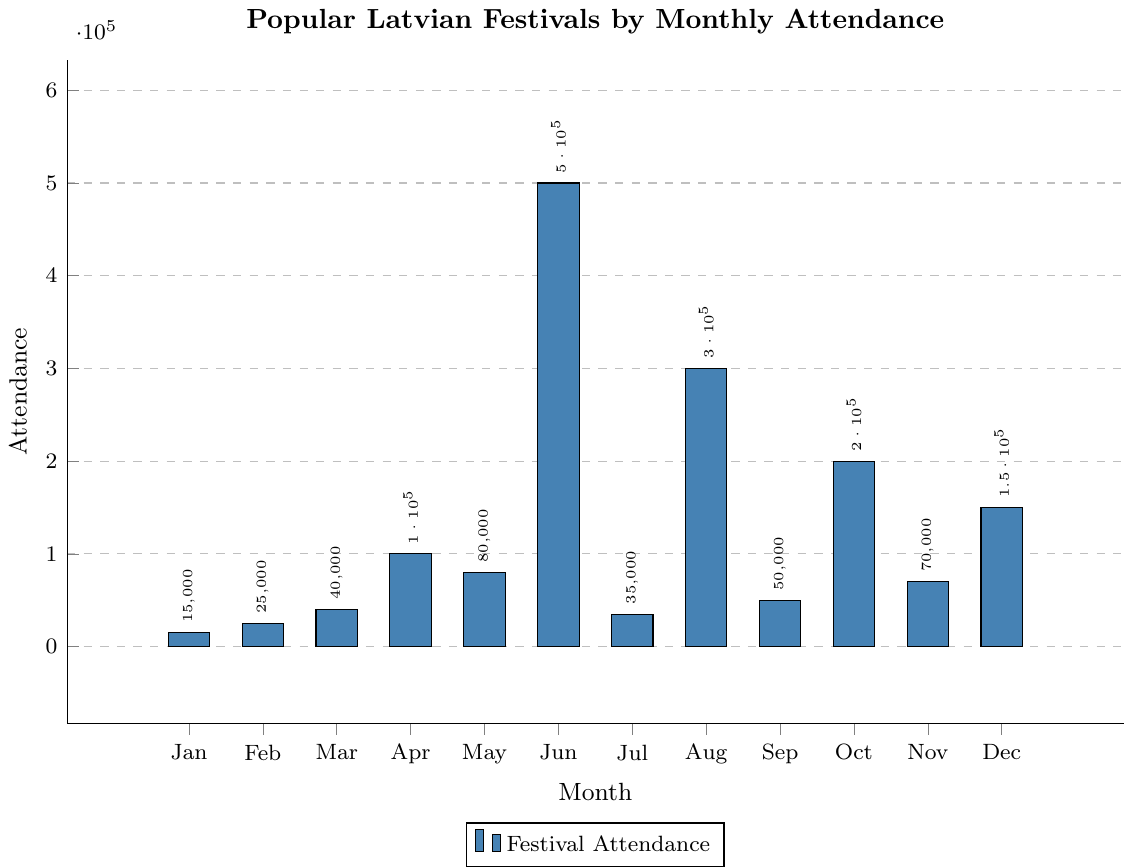Which festival has the highest attendance? The bar chart shows multiple festivals with varying attendance figures. The festival with the tallest bar has the highest attendance, which is Jāņi (Midsummer) with 500,000 attendees.
Answer: Jāņi (Midsummer) Which month has the lowest festival attendance? To find the month with the lowest attendance, look for the shortest bar in the chart. January, representing Meteņi, has the shortest bar with 15,000 attendees.
Answer: January What is the total attendance of festivals in August and October combined? Find the attendance for August (Rīgas Svētki) and October (Staro Rīga) from the chart. August has 300,000 attendees and October has 200,000 attendees. Adding these together gives 300,000 + 200,000 = 500,000.
Answer: 500,000 How much higher is the attendance for Christmas Markets in December compared to Maslenitsa in February? Find the attendance for Christmas Markets in December (150,000) and Maslenitsa in February (25,000). Subtract the February attendance from the December attendance: 150,000 - 25,000 = 125,000.
Answer: 125,000 Which festivals have an attendance greater than 200,000? Identify the bars taller than the 200,000 mark. The festivals are Jāņi (500,000), Rīgas Svētki (300,000), and Staro Rīga (200,000).
Answer: Jāņi, Rīgas Svētki, Staro Rīga What is the average attendance of festivals in February, March, and April? Summarize the attendance figures for February (25,000), March (40,000), and April (100,000). Add them up and divide by the number of months: (25,000 + 40,000 + 100,000) / 3 = 55,000.
Answer: 55,000 How does the attendance in June compare to the average attendance of all other months? First, find the annual total attendance excluding June: 15,000 (Jan) + 25,000 (Feb) + 40,000 (Mar) + 100,000 (Apr) + 80,000 (May) + 35,000 (Jul) + 300,000 (Aug) + 50,000 (Sep) + 200,000 (Oct) + 70,000 (Nov) + 150,000 (Dec) = 1,065,000. The average for the 11 months is 1,065,000 / 11 ≈ 96,818. June attendance (500,000) is much higher than the average of other months (96,818).
Answer: June's attendance is much higher Which month has a festival with double the attendance of the Easter Market in March? The Easter Market in March has an attendance of 40,000. Double this attendance is 80,000. May’s festival, Latvian Independence Restoration Day, has exactly 80,000 attendees.
Answer: May What is the total attendance across all festivals? Add the attendance figures for all months: 15,000 (Jan) + 25,000 (Feb) + 40,000 (Mar) + 100,000 (Apr) + 80,000 (May) + 500,000 (Jun) + 35,000 (Jul) + 300,000 (Aug) + 50,000 (Sep) + 200,000 (Oct) + 70,000 (Nov) + 150,000 (Dec) = 1,565,000.
Answer: 1,565,000 